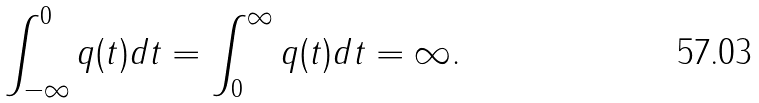<formula> <loc_0><loc_0><loc_500><loc_500>\int _ { - \infty } ^ { 0 } q ( t ) d t = \int _ { 0 } ^ { \infty } q ( t ) d t = \infty .</formula> 